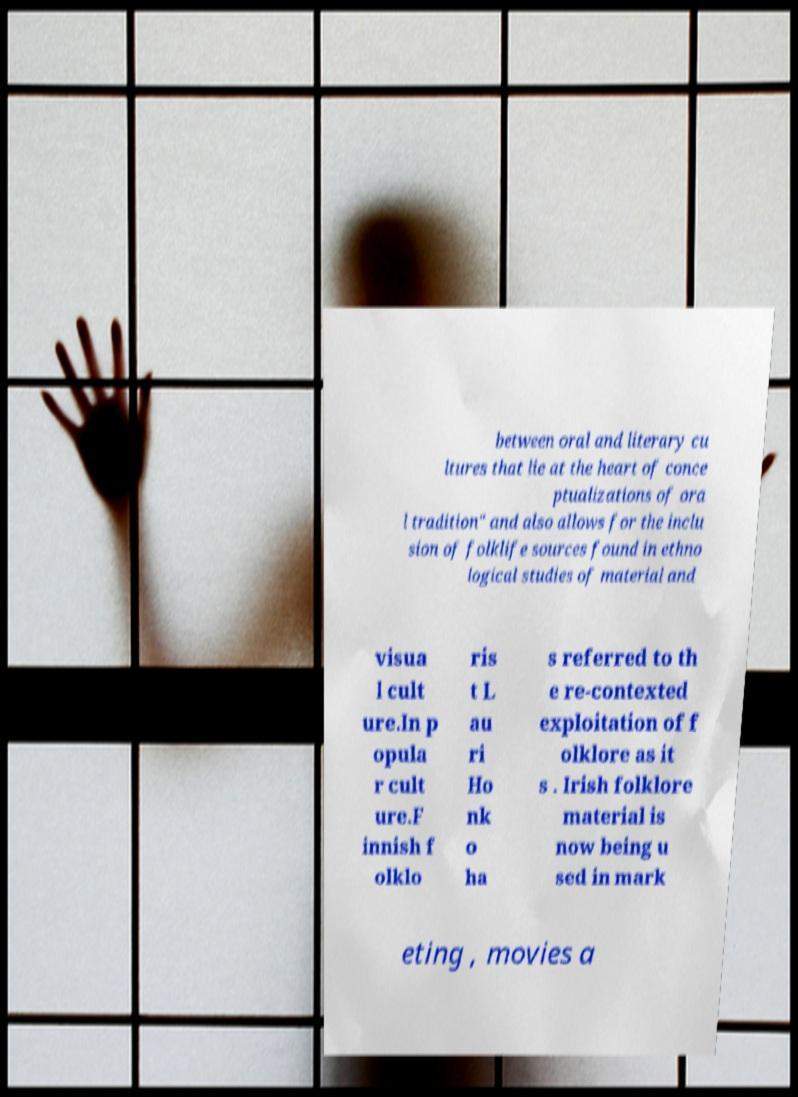For documentation purposes, I need the text within this image transcribed. Could you provide that? between oral and literary cu ltures that lie at the heart of conce ptualizations of ora l tradition" and also allows for the inclu sion of folklife sources found in ethno logical studies of material and visua l cult ure.In p opula r cult ure.F innish f olklo ris t L au ri Ho nk o ha s referred to th e re-contexted exploitation of f olklore as it s . Irish folklore material is now being u sed in mark eting , movies a 